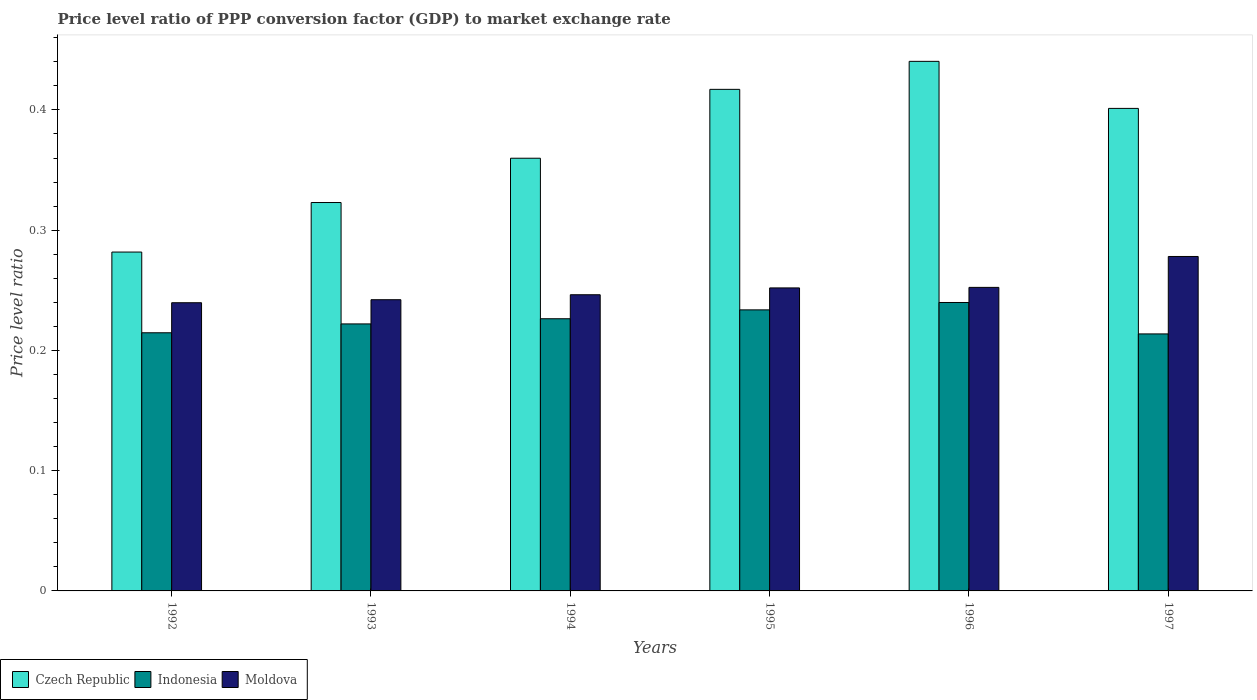How many different coloured bars are there?
Provide a short and direct response. 3. Are the number of bars per tick equal to the number of legend labels?
Your answer should be compact. Yes. Are the number of bars on each tick of the X-axis equal?
Keep it short and to the point. Yes. How many bars are there on the 1st tick from the left?
Give a very brief answer. 3. In how many cases, is the number of bars for a given year not equal to the number of legend labels?
Your answer should be very brief. 0. What is the price level ratio in Moldova in 1993?
Give a very brief answer. 0.24. Across all years, what is the maximum price level ratio in Czech Republic?
Keep it short and to the point. 0.44. Across all years, what is the minimum price level ratio in Indonesia?
Provide a short and direct response. 0.21. What is the total price level ratio in Czech Republic in the graph?
Keep it short and to the point. 2.22. What is the difference between the price level ratio in Indonesia in 1993 and that in 1996?
Your response must be concise. -0.02. What is the difference between the price level ratio in Czech Republic in 1997 and the price level ratio in Moldova in 1994?
Provide a succinct answer. 0.15. What is the average price level ratio in Indonesia per year?
Provide a short and direct response. 0.23. In the year 1992, what is the difference between the price level ratio in Indonesia and price level ratio in Moldova?
Provide a short and direct response. -0.02. What is the ratio of the price level ratio in Moldova in 1993 to that in 1997?
Your answer should be very brief. 0.87. Is the difference between the price level ratio in Indonesia in 1995 and 1996 greater than the difference between the price level ratio in Moldova in 1995 and 1996?
Ensure brevity in your answer.  No. What is the difference between the highest and the second highest price level ratio in Czech Republic?
Give a very brief answer. 0.02. What is the difference between the highest and the lowest price level ratio in Czech Republic?
Offer a very short reply. 0.16. What does the 2nd bar from the left in 1994 represents?
Ensure brevity in your answer.  Indonesia. What does the 2nd bar from the right in 1997 represents?
Offer a terse response. Indonesia. Is it the case that in every year, the sum of the price level ratio in Czech Republic and price level ratio in Indonesia is greater than the price level ratio in Moldova?
Offer a very short reply. Yes. How many years are there in the graph?
Your answer should be very brief. 6. Are the values on the major ticks of Y-axis written in scientific E-notation?
Your response must be concise. No. Does the graph contain grids?
Offer a very short reply. No. Where does the legend appear in the graph?
Give a very brief answer. Bottom left. How many legend labels are there?
Your answer should be compact. 3. What is the title of the graph?
Make the answer very short. Price level ratio of PPP conversion factor (GDP) to market exchange rate. What is the label or title of the X-axis?
Your answer should be very brief. Years. What is the label or title of the Y-axis?
Give a very brief answer. Price level ratio. What is the Price level ratio in Czech Republic in 1992?
Offer a very short reply. 0.28. What is the Price level ratio of Indonesia in 1992?
Offer a terse response. 0.21. What is the Price level ratio of Moldova in 1992?
Keep it short and to the point. 0.24. What is the Price level ratio of Czech Republic in 1993?
Offer a terse response. 0.32. What is the Price level ratio in Indonesia in 1993?
Your answer should be compact. 0.22. What is the Price level ratio of Moldova in 1993?
Make the answer very short. 0.24. What is the Price level ratio in Czech Republic in 1994?
Your answer should be very brief. 0.36. What is the Price level ratio in Indonesia in 1994?
Provide a succinct answer. 0.23. What is the Price level ratio of Moldova in 1994?
Offer a terse response. 0.25. What is the Price level ratio of Czech Republic in 1995?
Make the answer very short. 0.42. What is the Price level ratio of Indonesia in 1995?
Your answer should be very brief. 0.23. What is the Price level ratio in Moldova in 1995?
Offer a terse response. 0.25. What is the Price level ratio in Czech Republic in 1996?
Provide a succinct answer. 0.44. What is the Price level ratio of Indonesia in 1996?
Provide a short and direct response. 0.24. What is the Price level ratio in Moldova in 1996?
Provide a succinct answer. 0.25. What is the Price level ratio of Czech Republic in 1997?
Your response must be concise. 0.4. What is the Price level ratio in Indonesia in 1997?
Ensure brevity in your answer.  0.21. What is the Price level ratio in Moldova in 1997?
Provide a short and direct response. 0.28. Across all years, what is the maximum Price level ratio in Czech Republic?
Give a very brief answer. 0.44. Across all years, what is the maximum Price level ratio in Indonesia?
Offer a very short reply. 0.24. Across all years, what is the maximum Price level ratio in Moldova?
Keep it short and to the point. 0.28. Across all years, what is the minimum Price level ratio in Czech Republic?
Your response must be concise. 0.28. Across all years, what is the minimum Price level ratio in Indonesia?
Offer a terse response. 0.21. Across all years, what is the minimum Price level ratio in Moldova?
Ensure brevity in your answer.  0.24. What is the total Price level ratio of Czech Republic in the graph?
Ensure brevity in your answer.  2.22. What is the total Price level ratio of Indonesia in the graph?
Your response must be concise. 1.35. What is the total Price level ratio in Moldova in the graph?
Give a very brief answer. 1.51. What is the difference between the Price level ratio of Czech Republic in 1992 and that in 1993?
Provide a succinct answer. -0.04. What is the difference between the Price level ratio in Indonesia in 1992 and that in 1993?
Ensure brevity in your answer.  -0.01. What is the difference between the Price level ratio of Moldova in 1992 and that in 1993?
Make the answer very short. -0. What is the difference between the Price level ratio of Czech Republic in 1992 and that in 1994?
Offer a very short reply. -0.08. What is the difference between the Price level ratio of Indonesia in 1992 and that in 1994?
Offer a terse response. -0.01. What is the difference between the Price level ratio in Moldova in 1992 and that in 1994?
Provide a short and direct response. -0.01. What is the difference between the Price level ratio in Czech Republic in 1992 and that in 1995?
Your answer should be compact. -0.14. What is the difference between the Price level ratio in Indonesia in 1992 and that in 1995?
Give a very brief answer. -0.02. What is the difference between the Price level ratio of Moldova in 1992 and that in 1995?
Offer a very short reply. -0.01. What is the difference between the Price level ratio of Czech Republic in 1992 and that in 1996?
Ensure brevity in your answer.  -0.16. What is the difference between the Price level ratio in Indonesia in 1992 and that in 1996?
Provide a succinct answer. -0.03. What is the difference between the Price level ratio of Moldova in 1992 and that in 1996?
Your answer should be compact. -0.01. What is the difference between the Price level ratio in Czech Republic in 1992 and that in 1997?
Give a very brief answer. -0.12. What is the difference between the Price level ratio in Indonesia in 1992 and that in 1997?
Give a very brief answer. 0. What is the difference between the Price level ratio in Moldova in 1992 and that in 1997?
Provide a short and direct response. -0.04. What is the difference between the Price level ratio in Czech Republic in 1993 and that in 1994?
Ensure brevity in your answer.  -0.04. What is the difference between the Price level ratio in Indonesia in 1993 and that in 1994?
Offer a very short reply. -0. What is the difference between the Price level ratio of Moldova in 1993 and that in 1994?
Your answer should be compact. -0. What is the difference between the Price level ratio in Czech Republic in 1993 and that in 1995?
Offer a terse response. -0.09. What is the difference between the Price level ratio in Indonesia in 1993 and that in 1995?
Give a very brief answer. -0.01. What is the difference between the Price level ratio of Moldova in 1993 and that in 1995?
Offer a terse response. -0.01. What is the difference between the Price level ratio of Czech Republic in 1993 and that in 1996?
Offer a very short reply. -0.12. What is the difference between the Price level ratio of Indonesia in 1993 and that in 1996?
Keep it short and to the point. -0.02. What is the difference between the Price level ratio in Moldova in 1993 and that in 1996?
Provide a succinct answer. -0.01. What is the difference between the Price level ratio in Czech Republic in 1993 and that in 1997?
Your answer should be very brief. -0.08. What is the difference between the Price level ratio of Indonesia in 1993 and that in 1997?
Provide a succinct answer. 0.01. What is the difference between the Price level ratio in Moldova in 1993 and that in 1997?
Keep it short and to the point. -0.04. What is the difference between the Price level ratio in Czech Republic in 1994 and that in 1995?
Your response must be concise. -0.06. What is the difference between the Price level ratio of Indonesia in 1994 and that in 1995?
Provide a succinct answer. -0.01. What is the difference between the Price level ratio of Moldova in 1994 and that in 1995?
Your answer should be compact. -0.01. What is the difference between the Price level ratio of Czech Republic in 1994 and that in 1996?
Provide a short and direct response. -0.08. What is the difference between the Price level ratio of Indonesia in 1994 and that in 1996?
Offer a very short reply. -0.01. What is the difference between the Price level ratio in Moldova in 1994 and that in 1996?
Your answer should be very brief. -0.01. What is the difference between the Price level ratio of Czech Republic in 1994 and that in 1997?
Provide a succinct answer. -0.04. What is the difference between the Price level ratio of Indonesia in 1994 and that in 1997?
Keep it short and to the point. 0.01. What is the difference between the Price level ratio of Moldova in 1994 and that in 1997?
Your answer should be compact. -0.03. What is the difference between the Price level ratio of Czech Republic in 1995 and that in 1996?
Give a very brief answer. -0.02. What is the difference between the Price level ratio of Indonesia in 1995 and that in 1996?
Make the answer very short. -0.01. What is the difference between the Price level ratio in Moldova in 1995 and that in 1996?
Keep it short and to the point. -0. What is the difference between the Price level ratio in Czech Republic in 1995 and that in 1997?
Provide a succinct answer. 0.02. What is the difference between the Price level ratio in Moldova in 1995 and that in 1997?
Your answer should be compact. -0.03. What is the difference between the Price level ratio of Czech Republic in 1996 and that in 1997?
Your answer should be compact. 0.04. What is the difference between the Price level ratio in Indonesia in 1996 and that in 1997?
Provide a succinct answer. 0.03. What is the difference between the Price level ratio of Moldova in 1996 and that in 1997?
Your answer should be compact. -0.03. What is the difference between the Price level ratio in Czech Republic in 1992 and the Price level ratio in Indonesia in 1993?
Keep it short and to the point. 0.06. What is the difference between the Price level ratio of Czech Republic in 1992 and the Price level ratio of Moldova in 1993?
Keep it short and to the point. 0.04. What is the difference between the Price level ratio of Indonesia in 1992 and the Price level ratio of Moldova in 1993?
Your answer should be very brief. -0.03. What is the difference between the Price level ratio of Czech Republic in 1992 and the Price level ratio of Indonesia in 1994?
Make the answer very short. 0.06. What is the difference between the Price level ratio of Czech Republic in 1992 and the Price level ratio of Moldova in 1994?
Provide a short and direct response. 0.04. What is the difference between the Price level ratio of Indonesia in 1992 and the Price level ratio of Moldova in 1994?
Provide a succinct answer. -0.03. What is the difference between the Price level ratio of Czech Republic in 1992 and the Price level ratio of Indonesia in 1995?
Your answer should be very brief. 0.05. What is the difference between the Price level ratio in Czech Republic in 1992 and the Price level ratio in Moldova in 1995?
Offer a terse response. 0.03. What is the difference between the Price level ratio in Indonesia in 1992 and the Price level ratio in Moldova in 1995?
Keep it short and to the point. -0.04. What is the difference between the Price level ratio of Czech Republic in 1992 and the Price level ratio of Indonesia in 1996?
Give a very brief answer. 0.04. What is the difference between the Price level ratio of Czech Republic in 1992 and the Price level ratio of Moldova in 1996?
Provide a short and direct response. 0.03. What is the difference between the Price level ratio in Indonesia in 1992 and the Price level ratio in Moldova in 1996?
Offer a very short reply. -0.04. What is the difference between the Price level ratio of Czech Republic in 1992 and the Price level ratio of Indonesia in 1997?
Ensure brevity in your answer.  0.07. What is the difference between the Price level ratio of Czech Republic in 1992 and the Price level ratio of Moldova in 1997?
Offer a terse response. 0. What is the difference between the Price level ratio of Indonesia in 1992 and the Price level ratio of Moldova in 1997?
Provide a short and direct response. -0.06. What is the difference between the Price level ratio of Czech Republic in 1993 and the Price level ratio of Indonesia in 1994?
Keep it short and to the point. 0.1. What is the difference between the Price level ratio in Czech Republic in 1993 and the Price level ratio in Moldova in 1994?
Your answer should be compact. 0.08. What is the difference between the Price level ratio in Indonesia in 1993 and the Price level ratio in Moldova in 1994?
Your response must be concise. -0.02. What is the difference between the Price level ratio in Czech Republic in 1993 and the Price level ratio in Indonesia in 1995?
Make the answer very short. 0.09. What is the difference between the Price level ratio in Czech Republic in 1993 and the Price level ratio in Moldova in 1995?
Offer a very short reply. 0.07. What is the difference between the Price level ratio of Indonesia in 1993 and the Price level ratio of Moldova in 1995?
Provide a short and direct response. -0.03. What is the difference between the Price level ratio in Czech Republic in 1993 and the Price level ratio in Indonesia in 1996?
Provide a succinct answer. 0.08. What is the difference between the Price level ratio in Czech Republic in 1993 and the Price level ratio in Moldova in 1996?
Make the answer very short. 0.07. What is the difference between the Price level ratio of Indonesia in 1993 and the Price level ratio of Moldova in 1996?
Ensure brevity in your answer.  -0.03. What is the difference between the Price level ratio in Czech Republic in 1993 and the Price level ratio in Indonesia in 1997?
Your response must be concise. 0.11. What is the difference between the Price level ratio of Czech Republic in 1993 and the Price level ratio of Moldova in 1997?
Your response must be concise. 0.04. What is the difference between the Price level ratio in Indonesia in 1993 and the Price level ratio in Moldova in 1997?
Offer a terse response. -0.06. What is the difference between the Price level ratio in Czech Republic in 1994 and the Price level ratio in Indonesia in 1995?
Provide a succinct answer. 0.13. What is the difference between the Price level ratio in Czech Republic in 1994 and the Price level ratio in Moldova in 1995?
Your answer should be compact. 0.11. What is the difference between the Price level ratio of Indonesia in 1994 and the Price level ratio of Moldova in 1995?
Provide a succinct answer. -0.03. What is the difference between the Price level ratio in Czech Republic in 1994 and the Price level ratio in Indonesia in 1996?
Ensure brevity in your answer.  0.12. What is the difference between the Price level ratio of Czech Republic in 1994 and the Price level ratio of Moldova in 1996?
Offer a very short reply. 0.11. What is the difference between the Price level ratio in Indonesia in 1994 and the Price level ratio in Moldova in 1996?
Your answer should be very brief. -0.03. What is the difference between the Price level ratio in Czech Republic in 1994 and the Price level ratio in Indonesia in 1997?
Provide a succinct answer. 0.15. What is the difference between the Price level ratio in Czech Republic in 1994 and the Price level ratio in Moldova in 1997?
Your answer should be very brief. 0.08. What is the difference between the Price level ratio of Indonesia in 1994 and the Price level ratio of Moldova in 1997?
Your answer should be very brief. -0.05. What is the difference between the Price level ratio of Czech Republic in 1995 and the Price level ratio of Indonesia in 1996?
Offer a terse response. 0.18. What is the difference between the Price level ratio of Czech Republic in 1995 and the Price level ratio of Moldova in 1996?
Make the answer very short. 0.16. What is the difference between the Price level ratio in Indonesia in 1995 and the Price level ratio in Moldova in 1996?
Give a very brief answer. -0.02. What is the difference between the Price level ratio in Czech Republic in 1995 and the Price level ratio in Indonesia in 1997?
Your answer should be very brief. 0.2. What is the difference between the Price level ratio in Czech Republic in 1995 and the Price level ratio in Moldova in 1997?
Give a very brief answer. 0.14. What is the difference between the Price level ratio in Indonesia in 1995 and the Price level ratio in Moldova in 1997?
Provide a succinct answer. -0.04. What is the difference between the Price level ratio in Czech Republic in 1996 and the Price level ratio in Indonesia in 1997?
Give a very brief answer. 0.23. What is the difference between the Price level ratio in Czech Republic in 1996 and the Price level ratio in Moldova in 1997?
Your answer should be very brief. 0.16. What is the difference between the Price level ratio in Indonesia in 1996 and the Price level ratio in Moldova in 1997?
Provide a succinct answer. -0.04. What is the average Price level ratio in Czech Republic per year?
Ensure brevity in your answer.  0.37. What is the average Price level ratio in Indonesia per year?
Offer a very short reply. 0.23. What is the average Price level ratio of Moldova per year?
Ensure brevity in your answer.  0.25. In the year 1992, what is the difference between the Price level ratio of Czech Republic and Price level ratio of Indonesia?
Provide a short and direct response. 0.07. In the year 1992, what is the difference between the Price level ratio of Czech Republic and Price level ratio of Moldova?
Make the answer very short. 0.04. In the year 1992, what is the difference between the Price level ratio of Indonesia and Price level ratio of Moldova?
Your answer should be very brief. -0.03. In the year 1993, what is the difference between the Price level ratio of Czech Republic and Price level ratio of Indonesia?
Offer a terse response. 0.1. In the year 1993, what is the difference between the Price level ratio in Czech Republic and Price level ratio in Moldova?
Provide a succinct answer. 0.08. In the year 1993, what is the difference between the Price level ratio of Indonesia and Price level ratio of Moldova?
Your response must be concise. -0.02. In the year 1994, what is the difference between the Price level ratio of Czech Republic and Price level ratio of Indonesia?
Your answer should be compact. 0.13. In the year 1994, what is the difference between the Price level ratio of Czech Republic and Price level ratio of Moldova?
Provide a short and direct response. 0.11. In the year 1994, what is the difference between the Price level ratio of Indonesia and Price level ratio of Moldova?
Your response must be concise. -0.02. In the year 1995, what is the difference between the Price level ratio in Czech Republic and Price level ratio in Indonesia?
Provide a short and direct response. 0.18. In the year 1995, what is the difference between the Price level ratio in Czech Republic and Price level ratio in Moldova?
Keep it short and to the point. 0.17. In the year 1995, what is the difference between the Price level ratio in Indonesia and Price level ratio in Moldova?
Ensure brevity in your answer.  -0.02. In the year 1996, what is the difference between the Price level ratio of Czech Republic and Price level ratio of Indonesia?
Your answer should be very brief. 0.2. In the year 1996, what is the difference between the Price level ratio in Czech Republic and Price level ratio in Moldova?
Ensure brevity in your answer.  0.19. In the year 1996, what is the difference between the Price level ratio of Indonesia and Price level ratio of Moldova?
Provide a short and direct response. -0.01. In the year 1997, what is the difference between the Price level ratio in Czech Republic and Price level ratio in Indonesia?
Offer a very short reply. 0.19. In the year 1997, what is the difference between the Price level ratio of Czech Republic and Price level ratio of Moldova?
Provide a short and direct response. 0.12. In the year 1997, what is the difference between the Price level ratio of Indonesia and Price level ratio of Moldova?
Provide a succinct answer. -0.06. What is the ratio of the Price level ratio of Czech Republic in 1992 to that in 1993?
Offer a very short reply. 0.87. What is the ratio of the Price level ratio of Indonesia in 1992 to that in 1993?
Provide a short and direct response. 0.97. What is the ratio of the Price level ratio of Moldova in 1992 to that in 1993?
Your answer should be compact. 0.99. What is the ratio of the Price level ratio of Czech Republic in 1992 to that in 1994?
Provide a succinct answer. 0.78. What is the ratio of the Price level ratio in Indonesia in 1992 to that in 1994?
Ensure brevity in your answer.  0.95. What is the ratio of the Price level ratio of Czech Republic in 1992 to that in 1995?
Keep it short and to the point. 0.68. What is the ratio of the Price level ratio of Indonesia in 1992 to that in 1995?
Offer a very short reply. 0.92. What is the ratio of the Price level ratio of Moldova in 1992 to that in 1995?
Give a very brief answer. 0.95. What is the ratio of the Price level ratio in Czech Republic in 1992 to that in 1996?
Keep it short and to the point. 0.64. What is the ratio of the Price level ratio of Indonesia in 1992 to that in 1996?
Your answer should be very brief. 0.9. What is the ratio of the Price level ratio of Moldova in 1992 to that in 1996?
Provide a succinct answer. 0.95. What is the ratio of the Price level ratio in Czech Republic in 1992 to that in 1997?
Give a very brief answer. 0.7. What is the ratio of the Price level ratio of Indonesia in 1992 to that in 1997?
Provide a short and direct response. 1. What is the ratio of the Price level ratio of Moldova in 1992 to that in 1997?
Offer a terse response. 0.86. What is the ratio of the Price level ratio of Czech Republic in 1993 to that in 1994?
Provide a short and direct response. 0.9. What is the ratio of the Price level ratio in Moldova in 1993 to that in 1994?
Offer a terse response. 0.98. What is the ratio of the Price level ratio of Czech Republic in 1993 to that in 1995?
Your answer should be very brief. 0.77. What is the ratio of the Price level ratio in Indonesia in 1993 to that in 1995?
Offer a very short reply. 0.95. What is the ratio of the Price level ratio in Moldova in 1993 to that in 1995?
Make the answer very short. 0.96. What is the ratio of the Price level ratio in Czech Republic in 1993 to that in 1996?
Offer a terse response. 0.73. What is the ratio of the Price level ratio of Indonesia in 1993 to that in 1996?
Your answer should be very brief. 0.93. What is the ratio of the Price level ratio of Moldova in 1993 to that in 1996?
Your response must be concise. 0.96. What is the ratio of the Price level ratio of Czech Republic in 1993 to that in 1997?
Make the answer very short. 0.8. What is the ratio of the Price level ratio in Indonesia in 1993 to that in 1997?
Provide a succinct answer. 1.04. What is the ratio of the Price level ratio of Moldova in 1993 to that in 1997?
Provide a succinct answer. 0.87. What is the ratio of the Price level ratio of Czech Republic in 1994 to that in 1995?
Your response must be concise. 0.86. What is the ratio of the Price level ratio of Indonesia in 1994 to that in 1995?
Offer a very short reply. 0.97. What is the ratio of the Price level ratio in Moldova in 1994 to that in 1995?
Ensure brevity in your answer.  0.98. What is the ratio of the Price level ratio in Czech Republic in 1994 to that in 1996?
Offer a very short reply. 0.82. What is the ratio of the Price level ratio in Indonesia in 1994 to that in 1996?
Give a very brief answer. 0.94. What is the ratio of the Price level ratio of Moldova in 1994 to that in 1996?
Your answer should be very brief. 0.98. What is the ratio of the Price level ratio of Czech Republic in 1994 to that in 1997?
Provide a short and direct response. 0.9. What is the ratio of the Price level ratio in Indonesia in 1994 to that in 1997?
Your answer should be compact. 1.06. What is the ratio of the Price level ratio in Moldova in 1994 to that in 1997?
Ensure brevity in your answer.  0.89. What is the ratio of the Price level ratio in Czech Republic in 1995 to that in 1996?
Your answer should be very brief. 0.95. What is the ratio of the Price level ratio in Indonesia in 1995 to that in 1996?
Offer a terse response. 0.97. What is the ratio of the Price level ratio in Moldova in 1995 to that in 1996?
Your answer should be very brief. 1. What is the ratio of the Price level ratio of Czech Republic in 1995 to that in 1997?
Your response must be concise. 1.04. What is the ratio of the Price level ratio in Indonesia in 1995 to that in 1997?
Ensure brevity in your answer.  1.09. What is the ratio of the Price level ratio of Moldova in 1995 to that in 1997?
Provide a short and direct response. 0.91. What is the ratio of the Price level ratio in Czech Republic in 1996 to that in 1997?
Make the answer very short. 1.1. What is the ratio of the Price level ratio of Indonesia in 1996 to that in 1997?
Your response must be concise. 1.12. What is the ratio of the Price level ratio of Moldova in 1996 to that in 1997?
Your answer should be very brief. 0.91. What is the difference between the highest and the second highest Price level ratio in Czech Republic?
Your answer should be very brief. 0.02. What is the difference between the highest and the second highest Price level ratio of Indonesia?
Keep it short and to the point. 0.01. What is the difference between the highest and the second highest Price level ratio of Moldova?
Keep it short and to the point. 0.03. What is the difference between the highest and the lowest Price level ratio in Czech Republic?
Make the answer very short. 0.16. What is the difference between the highest and the lowest Price level ratio in Indonesia?
Give a very brief answer. 0.03. What is the difference between the highest and the lowest Price level ratio in Moldova?
Make the answer very short. 0.04. 